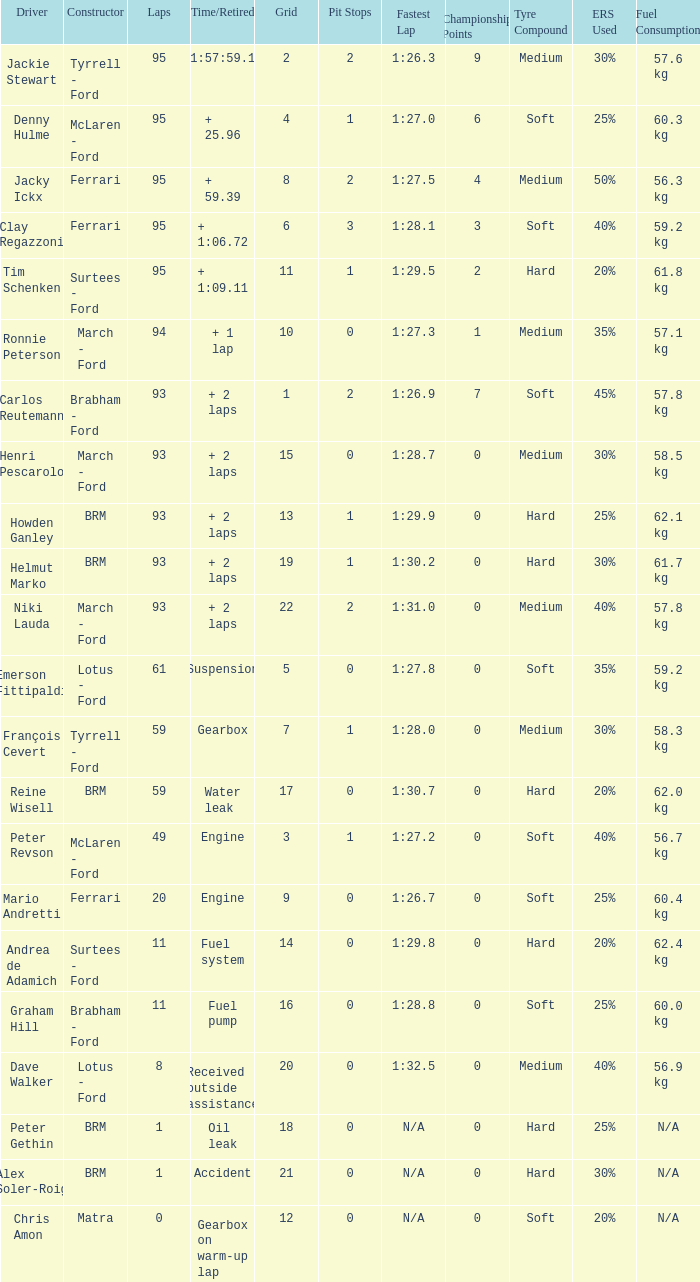What is the total number of grids for peter gethin? 18.0. 